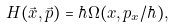Convert formula to latex. <formula><loc_0><loc_0><loc_500><loc_500>H ( \vec { x } , \vec { p } ) = \hbar { \Omega } ( x , p _ { x } / \hbar { ) } ,</formula> 